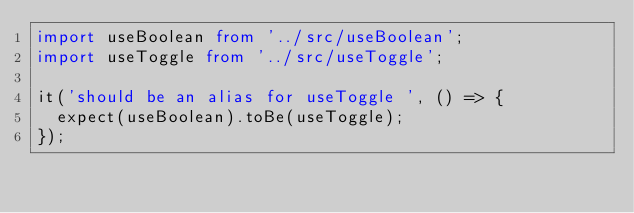<code> <loc_0><loc_0><loc_500><loc_500><_TypeScript_>import useBoolean from '../src/useBoolean';
import useToggle from '../src/useToggle';

it('should be an alias for useToggle ', () => {
  expect(useBoolean).toBe(useToggle);
});
</code> 